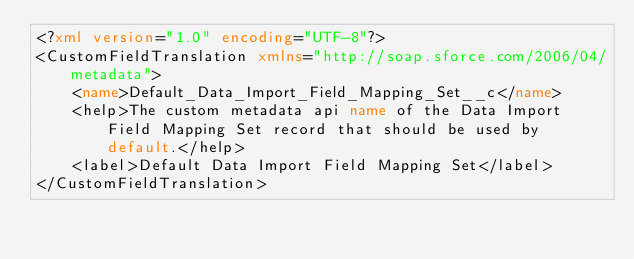<code> <loc_0><loc_0><loc_500><loc_500><_XML_><?xml version="1.0" encoding="UTF-8"?>
<CustomFieldTranslation xmlns="http://soap.sforce.com/2006/04/metadata">
    <name>Default_Data_Import_Field_Mapping_Set__c</name>
    <help>The custom metadata api name of the Data Import Field Mapping Set record that should be used by default.</help>
    <label>Default Data Import Field Mapping Set</label>
</CustomFieldTranslation>
</code> 